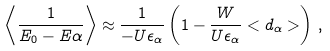Convert formula to latex. <formula><loc_0><loc_0><loc_500><loc_500>\left < \frac { 1 } { E _ { 0 } - E { \alpha } } \right > \approx \frac { 1 } { - U \epsilon _ { \alpha } } \left ( 1 - \frac { W } { U \epsilon _ { \alpha } } < d _ { \alpha } > \right ) \, ,</formula> 